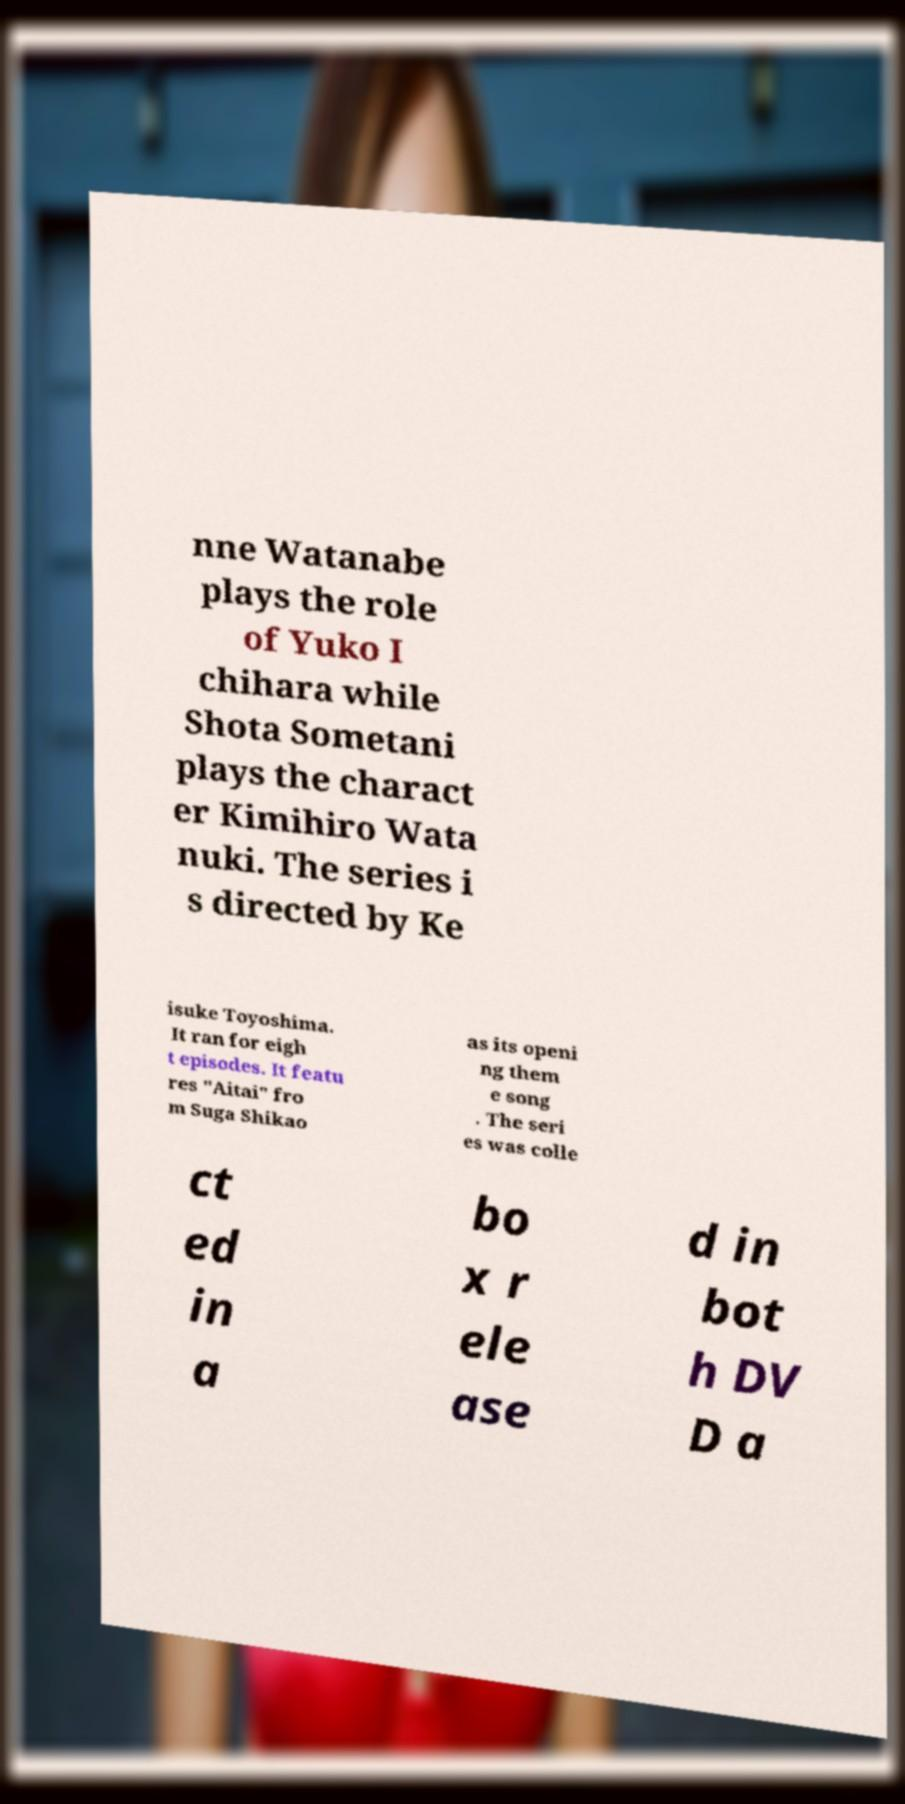There's text embedded in this image that I need extracted. Can you transcribe it verbatim? nne Watanabe plays the role of Yuko I chihara while Shota Sometani plays the charact er Kimihiro Wata nuki. The series i s directed by Ke isuke Toyoshima. It ran for eigh t episodes. It featu res "Aitai" fro m Suga Shikao as its openi ng them e song . The seri es was colle ct ed in a bo x r ele ase d in bot h DV D a 